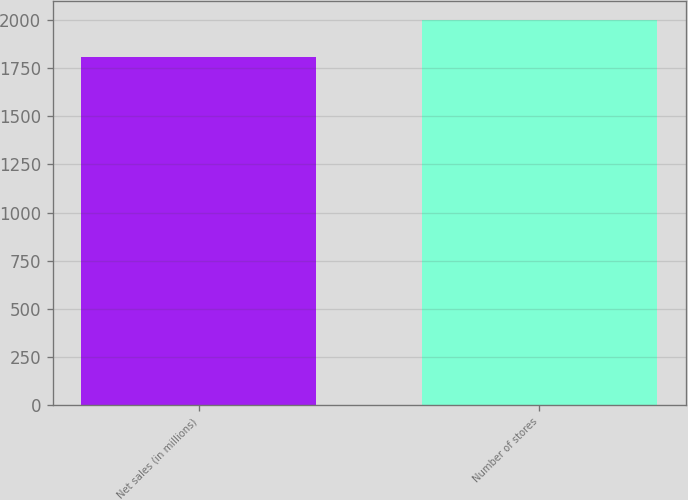<chart> <loc_0><loc_0><loc_500><loc_500><bar_chart><fcel>Net sales (in millions)<fcel>Number of stores<nl><fcel>1809.3<fcel>2000<nl></chart> 